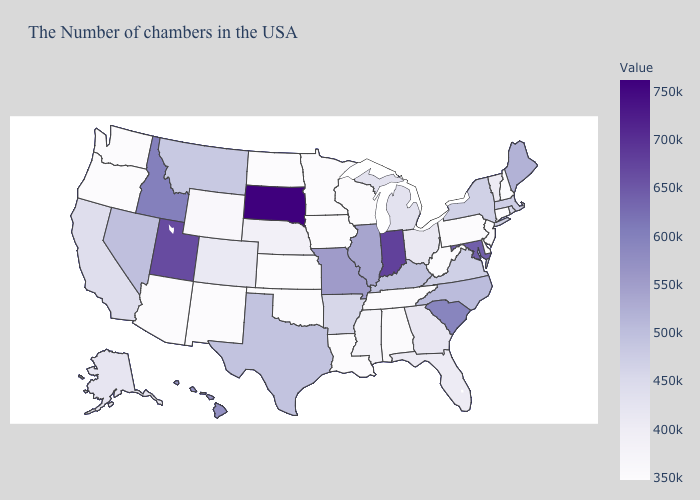Among the states that border New Jersey , which have the lowest value?
Short answer required. Delaware, Pennsylvania. 